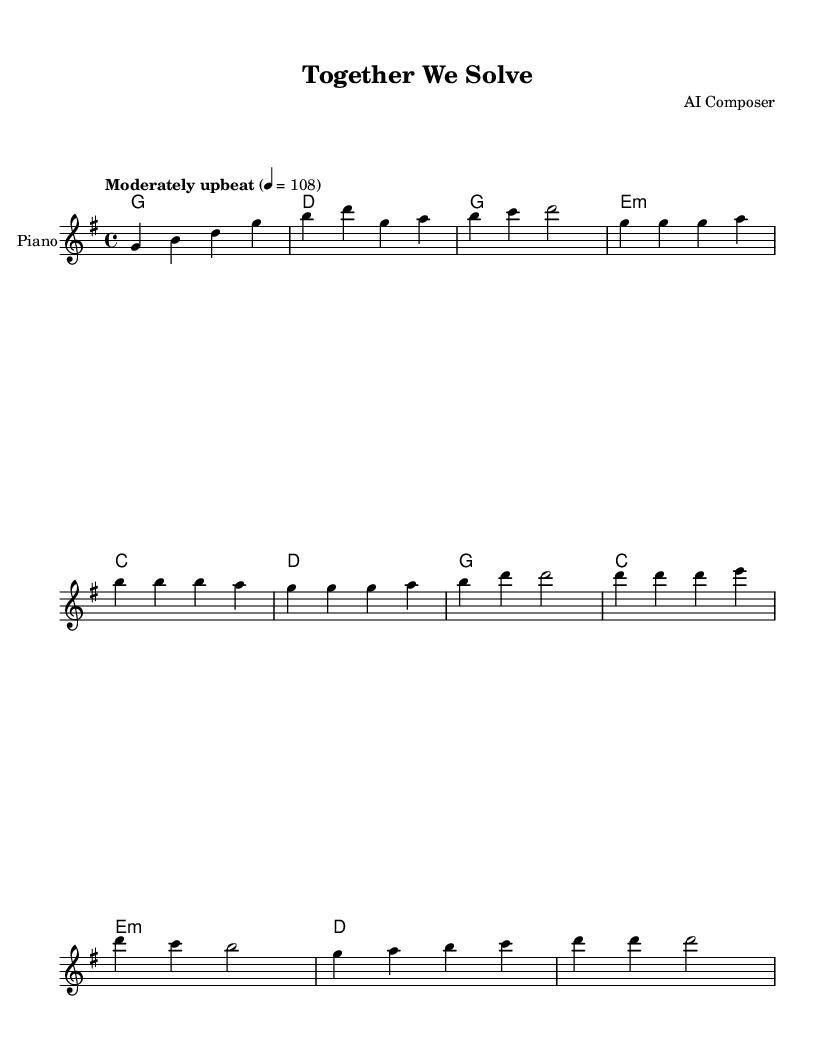What is the key signature of this music? The key signature is G major, which has one sharp (F#). This can be identified by looking at the beginning of the staff where the key signature is indicated.
Answer: G major What is the time signature of this music? The time signature is 4/4, which is indicated at the start of the piece. This means there are four beats in each measure, and the quarter note receives one beat.
Answer: 4/4 What is the tempo marking of this piece? The tempo marking is "Moderately upbeat" with a metronome marking of 108. This is provided at the start of the music in the tempo directives.
Answer: Moderately upbeat How many measures are there in the chorus section? The chorus consists of eight measures. By observing the structure of the music notated with the measures and counting them from the beginning of the chorus section, we can find the number.
Answer: 8 Which chord follows the first measure of the verse? The chord that follows the first measure of the verse is E minor. This can be verified by looking at the chord symbols written above the melody in the verse section.
Answer: E minor What is the primary theme expressed in the lyrics of this piece? The primary theme expressed in the lyrics revolves around unity and problem-solving together as a community. This is seen in phrases that emphasize collaboration and overcoming challenges.
Answer: Unity How does the music structure support the song's message? The song is structured with alternating verses and a chorus, which reinforces the message of teamwork by repeating the chorus after each verse, making the theme of collaboration more prominent through repetition.
Answer: Repetition 